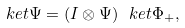Convert formula to latex. <formula><loc_0><loc_0><loc_500><loc_500>\ k e t { \Psi } = ( I \otimes \Psi ) \ k e t { \Phi _ { + } } ,</formula> 